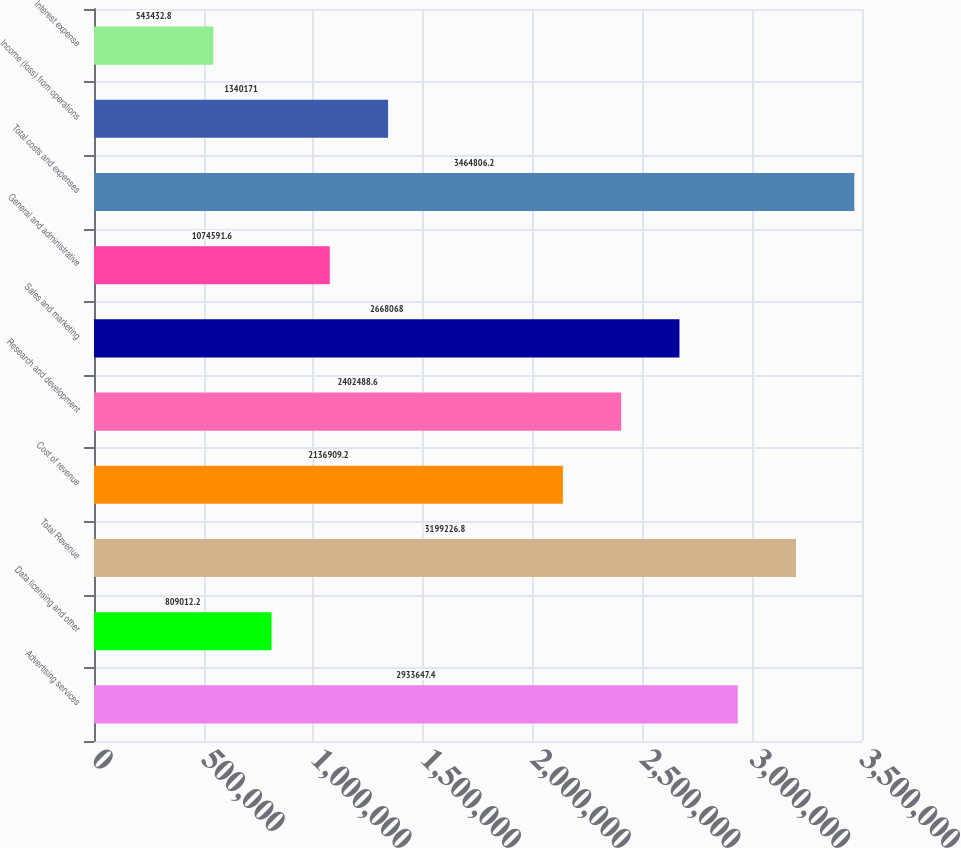Convert chart. <chart><loc_0><loc_0><loc_500><loc_500><bar_chart><fcel>Advertising services<fcel>Data licensing and other<fcel>Total Revenue<fcel>Cost of revenue<fcel>Research and development<fcel>Sales and marketing<fcel>General and administrative<fcel>Total costs and expenses<fcel>Income (loss) from operations<fcel>Interest expense<nl><fcel>2.93365e+06<fcel>809012<fcel>3.19923e+06<fcel>2.13691e+06<fcel>2.40249e+06<fcel>2.66807e+06<fcel>1.07459e+06<fcel>3.46481e+06<fcel>1.34017e+06<fcel>543433<nl></chart> 